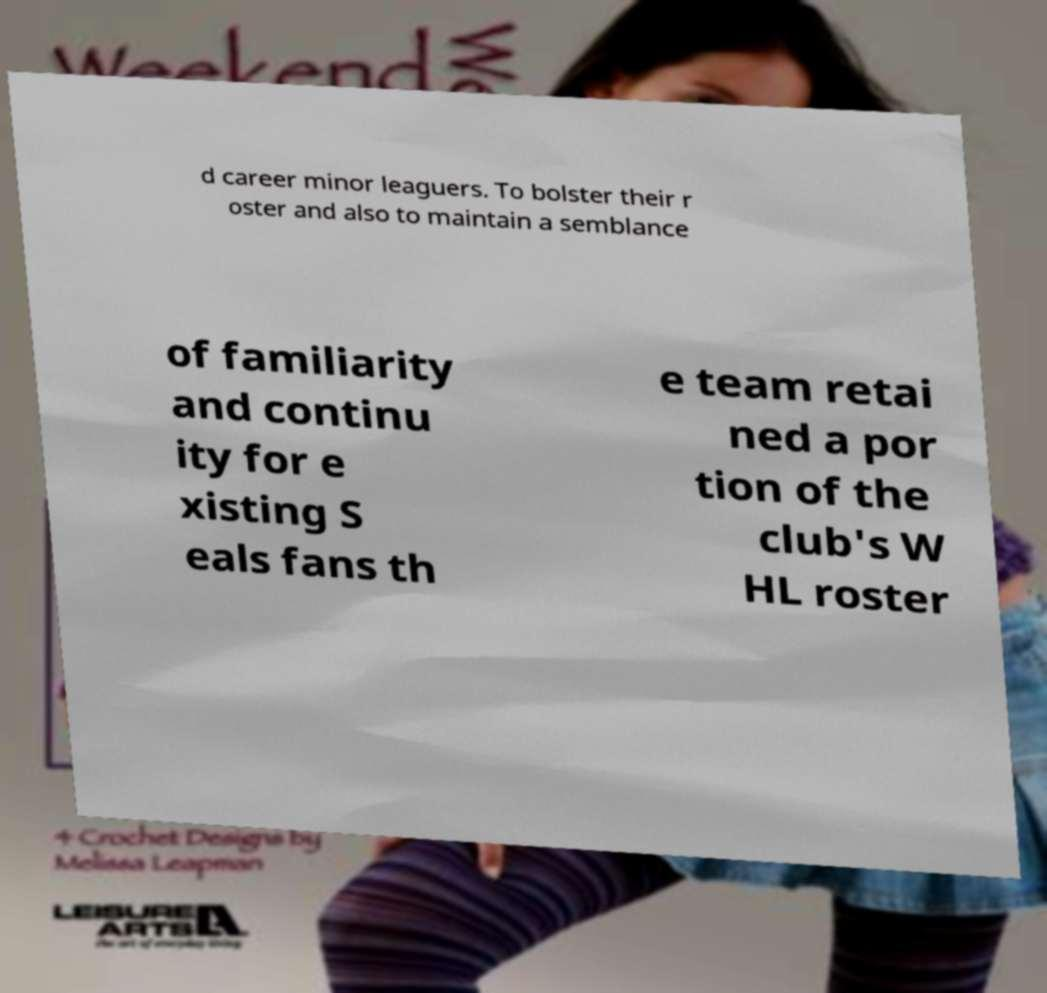Could you extract and type out the text from this image? d career minor leaguers. To bolster their r oster and also to maintain a semblance of familiarity and continu ity for e xisting S eals fans th e team retai ned a por tion of the club's W HL roster 